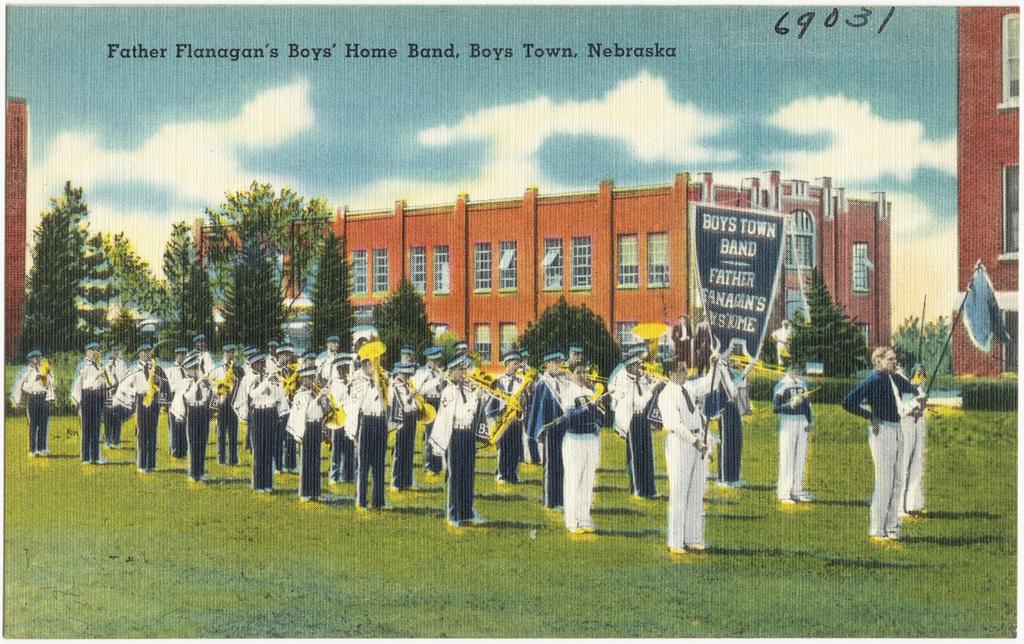What number is at the top of the picture?
Your response must be concise. 69031. What state are they in?
Ensure brevity in your answer.  Nebraska. 